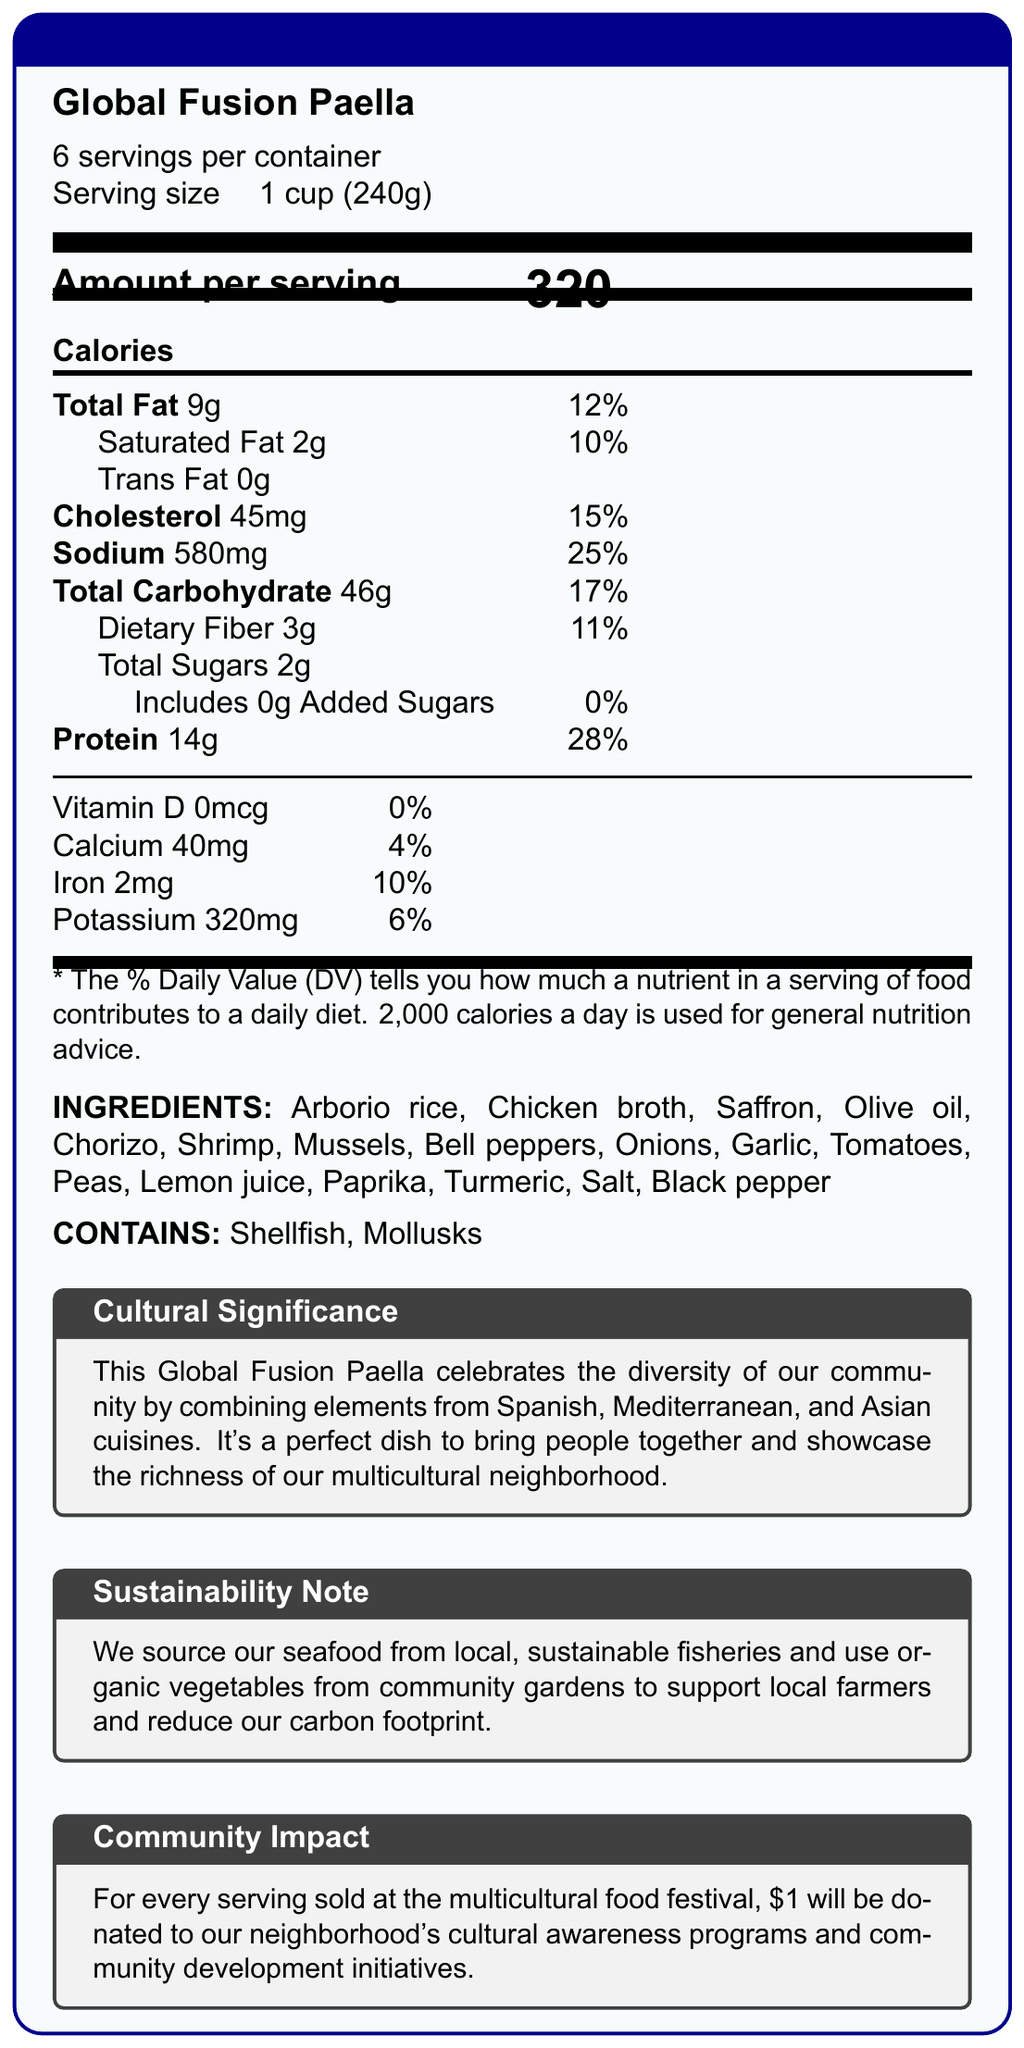what is the serving size for Global Fusion Paella? The document states the serving size as "1 cup (240g)".
Answer: 1 cup (240g) how many servings are there per container? The document mentions that there are 6 servings per container.
Answer: 6 how much saturated fat is in one serving? The document lists saturated fat content as 2g per serving.
Answer: 2g what are the main allergens in the Global Fusion Paella? The document states that the allergens are "Shellfish" and "Mollusks."
Answer: Shellfish, Mollusks what is the amount of sodium per serving in Global Fusion Paella? The document specifies that the sodium content is 580 mg per serving.
Answer: 580 mg how many grams of dietary fiber does one serving provide? The document lists dietary fiber content as 3g per serving.
Answer: 3g what percentage of the daily value for protein does one serving provide? The document specifies that one serving provides 28% of the daily value for protein.
Answer: 28% what cuisines does the Global Fusion Paella combine? A. Home-made and Mediterranean B. Mexican, Asian, and Mediterranean C. Spanish, Mediterranean, and Asian The document mentions that the dish combines elements from Spanish, Mediterranean, and Asian cuisines.
Answer: C what sustainability practices are mentioned for this dish? A. Organic vegetables from international farms B. Local and sustainable seafood sourcing C. Recycling plastic utensils The document states that they source seafood from local, sustainable fisheries and use organic vegetables from community gardens.
Answer: B how much iron is in one serving? The document lists the iron content as 2mg per serving.
Answer: 2mg does the Global Fusion Paella contain any added sugars? The document specifies that the amount of added sugars is 0g, indicating there are no added sugars.
Answer: No summarize the main idea of the document. The document details the nutritional content, ingredients, allergens, cultural significance, sustainability aspects, and community impact associated with the Global Fusion Paella.
Answer: The document provides the nutrition facts for Global Fusion Paella, highlighting its serving size, servings per container, calorie content, and detailed nutritional information. It also mentions the cultural significance of the dish, which combines Spanish, Mediterranean, and Asian cuisines, its sustainability efforts, and the positive community impact of donating $1 per serving sold to cultural awareness programs and community development initiatives. how much vitamin D is there in one serving? The document specifies that the vitamin D content is 0mcg per serving.
Answer: 0mcg how much will be donated to community initiatives if all servings in one container are sold? Each serving sold contributes $1, and with 6 servings per container, the total donation would be $6.
Answer: $6 what is the main protein source in the Global Fusion Paella? The main protein source is not explicitly mentioned; the ingredients list multiple protein sources like chorizo, shrimp, and mussels, making it unclear which is the main source.
Answer: Cannot be determined what percentage of the daily value for sodium does one serving of Global Fusion Paella provide? The document specifies that one serving provides 25% of the daily value for sodium.
Answer: 25% 